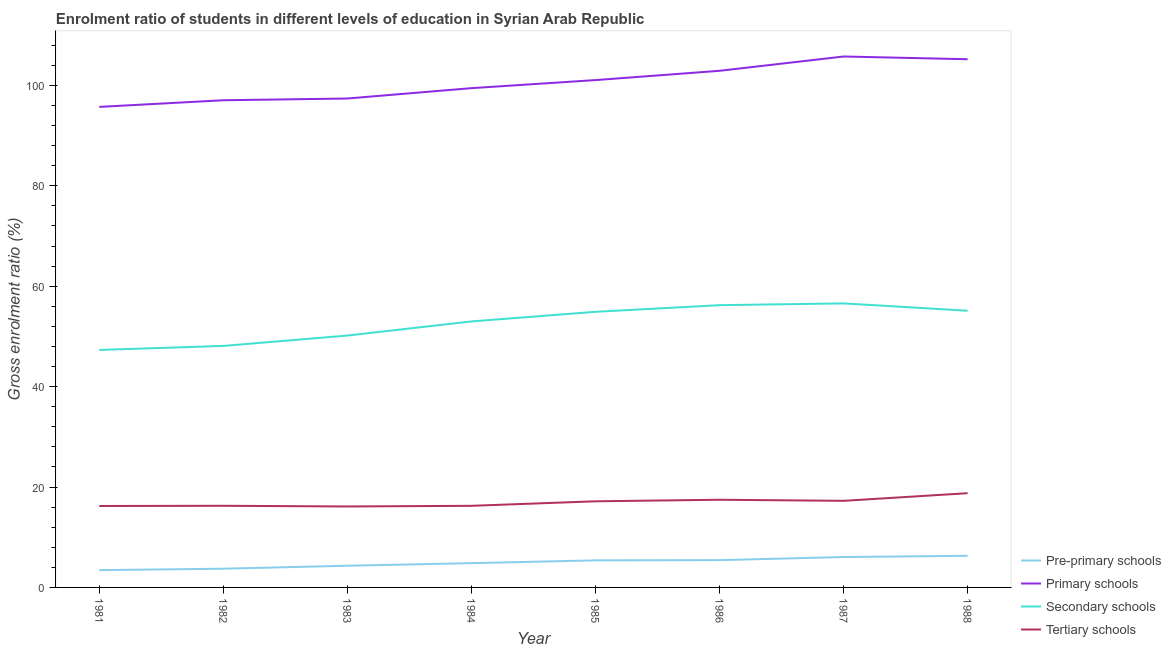Is the number of lines equal to the number of legend labels?
Make the answer very short. Yes. What is the gross enrolment ratio in secondary schools in 1985?
Your answer should be very brief. 54.9. Across all years, what is the maximum gross enrolment ratio in primary schools?
Make the answer very short. 105.76. Across all years, what is the minimum gross enrolment ratio in secondary schools?
Your answer should be very brief. 47.31. In which year was the gross enrolment ratio in pre-primary schools maximum?
Give a very brief answer. 1988. In which year was the gross enrolment ratio in pre-primary schools minimum?
Give a very brief answer. 1981. What is the total gross enrolment ratio in primary schools in the graph?
Your answer should be very brief. 804.57. What is the difference between the gross enrolment ratio in tertiary schools in 1982 and that in 1986?
Keep it short and to the point. -1.2. What is the difference between the gross enrolment ratio in pre-primary schools in 1984 and the gross enrolment ratio in secondary schools in 1985?
Your answer should be compact. -50.07. What is the average gross enrolment ratio in pre-primary schools per year?
Your response must be concise. 4.94. In the year 1986, what is the difference between the gross enrolment ratio in tertiary schools and gross enrolment ratio in secondary schools?
Give a very brief answer. -38.76. In how many years, is the gross enrolment ratio in pre-primary schools greater than 92 %?
Ensure brevity in your answer.  0. What is the ratio of the gross enrolment ratio in tertiary schools in 1985 to that in 1988?
Your answer should be compact. 0.91. Is the gross enrolment ratio in primary schools in 1981 less than that in 1987?
Your answer should be very brief. Yes. Is the difference between the gross enrolment ratio in secondary schools in 1984 and 1985 greater than the difference between the gross enrolment ratio in pre-primary schools in 1984 and 1985?
Your answer should be compact. No. What is the difference between the highest and the second highest gross enrolment ratio in primary schools?
Your response must be concise. 0.54. What is the difference between the highest and the lowest gross enrolment ratio in secondary schools?
Offer a terse response. 9.27. Is it the case that in every year, the sum of the gross enrolment ratio in primary schools and gross enrolment ratio in tertiary schools is greater than the sum of gross enrolment ratio in secondary schools and gross enrolment ratio in pre-primary schools?
Give a very brief answer. Yes. Is it the case that in every year, the sum of the gross enrolment ratio in pre-primary schools and gross enrolment ratio in primary schools is greater than the gross enrolment ratio in secondary schools?
Your response must be concise. Yes. Does the gross enrolment ratio in secondary schools monotonically increase over the years?
Your answer should be compact. No. Is the gross enrolment ratio in primary schools strictly greater than the gross enrolment ratio in secondary schools over the years?
Give a very brief answer. Yes. How many lines are there?
Your response must be concise. 4. Does the graph contain any zero values?
Your answer should be compact. No. What is the title of the graph?
Make the answer very short. Enrolment ratio of students in different levels of education in Syrian Arab Republic. What is the label or title of the X-axis?
Offer a very short reply. Year. What is the Gross enrolment ratio (%) of Pre-primary schools in 1981?
Offer a very short reply. 3.44. What is the Gross enrolment ratio (%) of Primary schools in 1981?
Provide a succinct answer. 95.72. What is the Gross enrolment ratio (%) in Secondary schools in 1981?
Provide a succinct answer. 47.31. What is the Gross enrolment ratio (%) in Tertiary schools in 1981?
Offer a very short reply. 16.22. What is the Gross enrolment ratio (%) in Pre-primary schools in 1982?
Give a very brief answer. 3.73. What is the Gross enrolment ratio (%) of Primary schools in 1982?
Offer a terse response. 97.05. What is the Gross enrolment ratio (%) in Secondary schools in 1982?
Offer a terse response. 48.11. What is the Gross enrolment ratio (%) in Tertiary schools in 1982?
Your response must be concise. 16.26. What is the Gross enrolment ratio (%) in Pre-primary schools in 1983?
Offer a very short reply. 4.32. What is the Gross enrolment ratio (%) of Primary schools in 1983?
Your answer should be very brief. 97.39. What is the Gross enrolment ratio (%) in Secondary schools in 1983?
Offer a terse response. 50.17. What is the Gross enrolment ratio (%) of Tertiary schools in 1983?
Your response must be concise. 16.13. What is the Gross enrolment ratio (%) of Pre-primary schools in 1984?
Your response must be concise. 4.84. What is the Gross enrolment ratio (%) of Primary schools in 1984?
Provide a succinct answer. 99.46. What is the Gross enrolment ratio (%) in Secondary schools in 1984?
Ensure brevity in your answer.  52.99. What is the Gross enrolment ratio (%) in Tertiary schools in 1984?
Your answer should be compact. 16.26. What is the Gross enrolment ratio (%) in Pre-primary schools in 1985?
Your answer should be compact. 5.39. What is the Gross enrolment ratio (%) in Primary schools in 1985?
Make the answer very short. 101.06. What is the Gross enrolment ratio (%) in Secondary schools in 1985?
Give a very brief answer. 54.9. What is the Gross enrolment ratio (%) in Tertiary schools in 1985?
Provide a short and direct response. 17.16. What is the Gross enrolment ratio (%) in Pre-primary schools in 1986?
Give a very brief answer. 5.44. What is the Gross enrolment ratio (%) in Primary schools in 1986?
Provide a short and direct response. 102.91. What is the Gross enrolment ratio (%) in Secondary schools in 1986?
Offer a very short reply. 56.23. What is the Gross enrolment ratio (%) of Tertiary schools in 1986?
Your response must be concise. 17.46. What is the Gross enrolment ratio (%) of Pre-primary schools in 1987?
Your answer should be compact. 6.05. What is the Gross enrolment ratio (%) in Primary schools in 1987?
Offer a very short reply. 105.76. What is the Gross enrolment ratio (%) in Secondary schools in 1987?
Offer a very short reply. 56.58. What is the Gross enrolment ratio (%) of Tertiary schools in 1987?
Give a very brief answer. 17.25. What is the Gross enrolment ratio (%) of Pre-primary schools in 1988?
Your answer should be compact. 6.3. What is the Gross enrolment ratio (%) in Primary schools in 1988?
Offer a very short reply. 105.22. What is the Gross enrolment ratio (%) of Secondary schools in 1988?
Your answer should be compact. 55.12. What is the Gross enrolment ratio (%) of Tertiary schools in 1988?
Offer a very short reply. 18.77. Across all years, what is the maximum Gross enrolment ratio (%) of Pre-primary schools?
Ensure brevity in your answer.  6.3. Across all years, what is the maximum Gross enrolment ratio (%) in Primary schools?
Offer a terse response. 105.76. Across all years, what is the maximum Gross enrolment ratio (%) in Secondary schools?
Offer a terse response. 56.58. Across all years, what is the maximum Gross enrolment ratio (%) in Tertiary schools?
Give a very brief answer. 18.77. Across all years, what is the minimum Gross enrolment ratio (%) in Pre-primary schools?
Your answer should be compact. 3.44. Across all years, what is the minimum Gross enrolment ratio (%) of Primary schools?
Provide a short and direct response. 95.72. Across all years, what is the minimum Gross enrolment ratio (%) of Secondary schools?
Offer a terse response. 47.31. Across all years, what is the minimum Gross enrolment ratio (%) of Tertiary schools?
Give a very brief answer. 16.13. What is the total Gross enrolment ratio (%) in Pre-primary schools in the graph?
Provide a short and direct response. 39.51. What is the total Gross enrolment ratio (%) in Primary schools in the graph?
Offer a terse response. 804.57. What is the total Gross enrolment ratio (%) of Secondary schools in the graph?
Your answer should be compact. 421.41. What is the total Gross enrolment ratio (%) in Tertiary schools in the graph?
Offer a very short reply. 135.52. What is the difference between the Gross enrolment ratio (%) in Pre-primary schools in 1981 and that in 1982?
Your response must be concise. -0.28. What is the difference between the Gross enrolment ratio (%) in Primary schools in 1981 and that in 1982?
Provide a short and direct response. -1.32. What is the difference between the Gross enrolment ratio (%) in Secondary schools in 1981 and that in 1982?
Your answer should be compact. -0.8. What is the difference between the Gross enrolment ratio (%) of Tertiary schools in 1981 and that in 1982?
Give a very brief answer. -0.04. What is the difference between the Gross enrolment ratio (%) of Pre-primary schools in 1981 and that in 1983?
Provide a succinct answer. -0.88. What is the difference between the Gross enrolment ratio (%) of Primary schools in 1981 and that in 1983?
Offer a very short reply. -1.67. What is the difference between the Gross enrolment ratio (%) in Secondary schools in 1981 and that in 1983?
Your answer should be very brief. -2.87. What is the difference between the Gross enrolment ratio (%) in Tertiary schools in 1981 and that in 1983?
Make the answer very short. 0.09. What is the difference between the Gross enrolment ratio (%) of Pre-primary schools in 1981 and that in 1984?
Your answer should be very brief. -1.39. What is the difference between the Gross enrolment ratio (%) in Primary schools in 1981 and that in 1984?
Offer a terse response. -3.73. What is the difference between the Gross enrolment ratio (%) in Secondary schools in 1981 and that in 1984?
Your response must be concise. -5.68. What is the difference between the Gross enrolment ratio (%) of Tertiary schools in 1981 and that in 1984?
Your answer should be compact. -0.04. What is the difference between the Gross enrolment ratio (%) of Pre-primary schools in 1981 and that in 1985?
Offer a very short reply. -1.95. What is the difference between the Gross enrolment ratio (%) of Primary schools in 1981 and that in 1985?
Give a very brief answer. -5.34. What is the difference between the Gross enrolment ratio (%) of Secondary schools in 1981 and that in 1985?
Make the answer very short. -7.6. What is the difference between the Gross enrolment ratio (%) of Tertiary schools in 1981 and that in 1985?
Give a very brief answer. -0.94. What is the difference between the Gross enrolment ratio (%) in Pre-primary schools in 1981 and that in 1986?
Provide a succinct answer. -1.99. What is the difference between the Gross enrolment ratio (%) in Primary schools in 1981 and that in 1986?
Ensure brevity in your answer.  -7.19. What is the difference between the Gross enrolment ratio (%) in Secondary schools in 1981 and that in 1986?
Keep it short and to the point. -8.92. What is the difference between the Gross enrolment ratio (%) in Tertiary schools in 1981 and that in 1986?
Provide a succinct answer. -1.24. What is the difference between the Gross enrolment ratio (%) of Pre-primary schools in 1981 and that in 1987?
Your answer should be compact. -2.61. What is the difference between the Gross enrolment ratio (%) of Primary schools in 1981 and that in 1987?
Your response must be concise. -10.04. What is the difference between the Gross enrolment ratio (%) in Secondary schools in 1981 and that in 1987?
Keep it short and to the point. -9.27. What is the difference between the Gross enrolment ratio (%) in Tertiary schools in 1981 and that in 1987?
Keep it short and to the point. -1.03. What is the difference between the Gross enrolment ratio (%) of Pre-primary schools in 1981 and that in 1988?
Your answer should be compact. -2.86. What is the difference between the Gross enrolment ratio (%) in Primary schools in 1981 and that in 1988?
Offer a terse response. -9.49. What is the difference between the Gross enrolment ratio (%) in Secondary schools in 1981 and that in 1988?
Ensure brevity in your answer.  -7.81. What is the difference between the Gross enrolment ratio (%) of Tertiary schools in 1981 and that in 1988?
Give a very brief answer. -2.55. What is the difference between the Gross enrolment ratio (%) of Pre-primary schools in 1982 and that in 1983?
Give a very brief answer. -0.59. What is the difference between the Gross enrolment ratio (%) in Primary schools in 1982 and that in 1983?
Offer a very short reply. -0.35. What is the difference between the Gross enrolment ratio (%) in Secondary schools in 1982 and that in 1983?
Offer a terse response. -2.07. What is the difference between the Gross enrolment ratio (%) in Tertiary schools in 1982 and that in 1983?
Offer a terse response. 0.13. What is the difference between the Gross enrolment ratio (%) in Pre-primary schools in 1982 and that in 1984?
Your response must be concise. -1.11. What is the difference between the Gross enrolment ratio (%) of Primary schools in 1982 and that in 1984?
Offer a terse response. -2.41. What is the difference between the Gross enrolment ratio (%) in Secondary schools in 1982 and that in 1984?
Provide a succinct answer. -4.88. What is the difference between the Gross enrolment ratio (%) of Tertiary schools in 1982 and that in 1984?
Your answer should be very brief. 0. What is the difference between the Gross enrolment ratio (%) in Pre-primary schools in 1982 and that in 1985?
Offer a terse response. -1.66. What is the difference between the Gross enrolment ratio (%) of Primary schools in 1982 and that in 1985?
Your answer should be compact. -4.02. What is the difference between the Gross enrolment ratio (%) in Secondary schools in 1982 and that in 1985?
Make the answer very short. -6.8. What is the difference between the Gross enrolment ratio (%) in Tertiary schools in 1982 and that in 1985?
Your answer should be very brief. -0.9. What is the difference between the Gross enrolment ratio (%) of Pre-primary schools in 1982 and that in 1986?
Offer a very short reply. -1.71. What is the difference between the Gross enrolment ratio (%) in Primary schools in 1982 and that in 1986?
Keep it short and to the point. -5.87. What is the difference between the Gross enrolment ratio (%) of Secondary schools in 1982 and that in 1986?
Offer a terse response. -8.12. What is the difference between the Gross enrolment ratio (%) in Tertiary schools in 1982 and that in 1986?
Ensure brevity in your answer.  -1.2. What is the difference between the Gross enrolment ratio (%) of Pre-primary schools in 1982 and that in 1987?
Keep it short and to the point. -2.33. What is the difference between the Gross enrolment ratio (%) in Primary schools in 1982 and that in 1987?
Offer a very short reply. -8.71. What is the difference between the Gross enrolment ratio (%) of Secondary schools in 1982 and that in 1987?
Provide a succinct answer. -8.47. What is the difference between the Gross enrolment ratio (%) in Tertiary schools in 1982 and that in 1987?
Make the answer very short. -0.99. What is the difference between the Gross enrolment ratio (%) of Pre-primary schools in 1982 and that in 1988?
Provide a succinct answer. -2.57. What is the difference between the Gross enrolment ratio (%) in Primary schools in 1982 and that in 1988?
Your response must be concise. -8.17. What is the difference between the Gross enrolment ratio (%) of Secondary schools in 1982 and that in 1988?
Offer a terse response. -7.01. What is the difference between the Gross enrolment ratio (%) in Tertiary schools in 1982 and that in 1988?
Provide a short and direct response. -2.51. What is the difference between the Gross enrolment ratio (%) of Pre-primary schools in 1983 and that in 1984?
Offer a terse response. -0.52. What is the difference between the Gross enrolment ratio (%) in Primary schools in 1983 and that in 1984?
Offer a very short reply. -2.06. What is the difference between the Gross enrolment ratio (%) in Secondary schools in 1983 and that in 1984?
Keep it short and to the point. -2.81. What is the difference between the Gross enrolment ratio (%) of Tertiary schools in 1983 and that in 1984?
Provide a short and direct response. -0.13. What is the difference between the Gross enrolment ratio (%) of Pre-primary schools in 1983 and that in 1985?
Your answer should be very brief. -1.07. What is the difference between the Gross enrolment ratio (%) of Primary schools in 1983 and that in 1985?
Offer a terse response. -3.67. What is the difference between the Gross enrolment ratio (%) in Secondary schools in 1983 and that in 1985?
Your response must be concise. -4.73. What is the difference between the Gross enrolment ratio (%) in Tertiary schools in 1983 and that in 1985?
Ensure brevity in your answer.  -1.03. What is the difference between the Gross enrolment ratio (%) in Pre-primary schools in 1983 and that in 1986?
Your answer should be compact. -1.12. What is the difference between the Gross enrolment ratio (%) in Primary schools in 1983 and that in 1986?
Make the answer very short. -5.52. What is the difference between the Gross enrolment ratio (%) in Secondary schools in 1983 and that in 1986?
Give a very brief answer. -6.05. What is the difference between the Gross enrolment ratio (%) in Tertiary schools in 1983 and that in 1986?
Your answer should be compact. -1.34. What is the difference between the Gross enrolment ratio (%) of Pre-primary schools in 1983 and that in 1987?
Your answer should be very brief. -1.73. What is the difference between the Gross enrolment ratio (%) of Primary schools in 1983 and that in 1987?
Ensure brevity in your answer.  -8.37. What is the difference between the Gross enrolment ratio (%) in Secondary schools in 1983 and that in 1987?
Offer a very short reply. -6.41. What is the difference between the Gross enrolment ratio (%) of Tertiary schools in 1983 and that in 1987?
Your response must be concise. -1.12. What is the difference between the Gross enrolment ratio (%) of Pre-primary schools in 1983 and that in 1988?
Provide a succinct answer. -1.98. What is the difference between the Gross enrolment ratio (%) in Primary schools in 1983 and that in 1988?
Provide a short and direct response. -7.82. What is the difference between the Gross enrolment ratio (%) in Secondary schools in 1983 and that in 1988?
Make the answer very short. -4.94. What is the difference between the Gross enrolment ratio (%) in Tertiary schools in 1983 and that in 1988?
Your response must be concise. -2.64. What is the difference between the Gross enrolment ratio (%) of Pre-primary schools in 1984 and that in 1985?
Make the answer very short. -0.56. What is the difference between the Gross enrolment ratio (%) of Primary schools in 1984 and that in 1985?
Provide a succinct answer. -1.61. What is the difference between the Gross enrolment ratio (%) of Secondary schools in 1984 and that in 1985?
Ensure brevity in your answer.  -1.92. What is the difference between the Gross enrolment ratio (%) of Tertiary schools in 1984 and that in 1985?
Keep it short and to the point. -0.9. What is the difference between the Gross enrolment ratio (%) in Pre-primary schools in 1984 and that in 1986?
Your answer should be compact. -0.6. What is the difference between the Gross enrolment ratio (%) in Primary schools in 1984 and that in 1986?
Offer a terse response. -3.46. What is the difference between the Gross enrolment ratio (%) of Secondary schools in 1984 and that in 1986?
Your response must be concise. -3.24. What is the difference between the Gross enrolment ratio (%) of Tertiary schools in 1984 and that in 1986?
Offer a very short reply. -1.21. What is the difference between the Gross enrolment ratio (%) of Pre-primary schools in 1984 and that in 1987?
Your answer should be compact. -1.22. What is the difference between the Gross enrolment ratio (%) in Primary schools in 1984 and that in 1987?
Provide a short and direct response. -6.3. What is the difference between the Gross enrolment ratio (%) of Secondary schools in 1984 and that in 1987?
Provide a succinct answer. -3.59. What is the difference between the Gross enrolment ratio (%) of Tertiary schools in 1984 and that in 1987?
Offer a terse response. -0.99. What is the difference between the Gross enrolment ratio (%) in Pre-primary schools in 1984 and that in 1988?
Make the answer very short. -1.47. What is the difference between the Gross enrolment ratio (%) in Primary schools in 1984 and that in 1988?
Keep it short and to the point. -5.76. What is the difference between the Gross enrolment ratio (%) in Secondary schools in 1984 and that in 1988?
Give a very brief answer. -2.13. What is the difference between the Gross enrolment ratio (%) in Tertiary schools in 1984 and that in 1988?
Your answer should be very brief. -2.51. What is the difference between the Gross enrolment ratio (%) of Pre-primary schools in 1985 and that in 1986?
Provide a short and direct response. -0.04. What is the difference between the Gross enrolment ratio (%) in Primary schools in 1985 and that in 1986?
Give a very brief answer. -1.85. What is the difference between the Gross enrolment ratio (%) of Secondary schools in 1985 and that in 1986?
Keep it short and to the point. -1.32. What is the difference between the Gross enrolment ratio (%) in Tertiary schools in 1985 and that in 1986?
Keep it short and to the point. -0.31. What is the difference between the Gross enrolment ratio (%) in Pre-primary schools in 1985 and that in 1987?
Your answer should be compact. -0.66. What is the difference between the Gross enrolment ratio (%) of Primary schools in 1985 and that in 1987?
Keep it short and to the point. -4.7. What is the difference between the Gross enrolment ratio (%) of Secondary schools in 1985 and that in 1987?
Your answer should be very brief. -1.68. What is the difference between the Gross enrolment ratio (%) in Tertiary schools in 1985 and that in 1987?
Provide a succinct answer. -0.09. What is the difference between the Gross enrolment ratio (%) of Pre-primary schools in 1985 and that in 1988?
Ensure brevity in your answer.  -0.91. What is the difference between the Gross enrolment ratio (%) of Primary schools in 1985 and that in 1988?
Keep it short and to the point. -4.16. What is the difference between the Gross enrolment ratio (%) of Secondary schools in 1985 and that in 1988?
Your response must be concise. -0.21. What is the difference between the Gross enrolment ratio (%) of Tertiary schools in 1985 and that in 1988?
Keep it short and to the point. -1.61. What is the difference between the Gross enrolment ratio (%) in Pre-primary schools in 1986 and that in 1987?
Provide a succinct answer. -0.62. What is the difference between the Gross enrolment ratio (%) of Primary schools in 1986 and that in 1987?
Your response must be concise. -2.85. What is the difference between the Gross enrolment ratio (%) in Secondary schools in 1986 and that in 1987?
Offer a terse response. -0.35. What is the difference between the Gross enrolment ratio (%) in Tertiary schools in 1986 and that in 1987?
Your answer should be compact. 0.21. What is the difference between the Gross enrolment ratio (%) of Pre-primary schools in 1986 and that in 1988?
Your response must be concise. -0.87. What is the difference between the Gross enrolment ratio (%) in Primary schools in 1986 and that in 1988?
Provide a succinct answer. -2.31. What is the difference between the Gross enrolment ratio (%) in Secondary schools in 1986 and that in 1988?
Provide a short and direct response. 1.11. What is the difference between the Gross enrolment ratio (%) of Tertiary schools in 1986 and that in 1988?
Offer a terse response. -1.31. What is the difference between the Gross enrolment ratio (%) of Pre-primary schools in 1987 and that in 1988?
Offer a terse response. -0.25. What is the difference between the Gross enrolment ratio (%) of Primary schools in 1987 and that in 1988?
Your answer should be very brief. 0.54. What is the difference between the Gross enrolment ratio (%) in Secondary schools in 1987 and that in 1988?
Ensure brevity in your answer.  1.46. What is the difference between the Gross enrolment ratio (%) in Tertiary schools in 1987 and that in 1988?
Offer a very short reply. -1.52. What is the difference between the Gross enrolment ratio (%) in Pre-primary schools in 1981 and the Gross enrolment ratio (%) in Primary schools in 1982?
Your answer should be compact. -93.6. What is the difference between the Gross enrolment ratio (%) in Pre-primary schools in 1981 and the Gross enrolment ratio (%) in Secondary schools in 1982?
Make the answer very short. -44.66. What is the difference between the Gross enrolment ratio (%) of Pre-primary schools in 1981 and the Gross enrolment ratio (%) of Tertiary schools in 1982?
Keep it short and to the point. -12.82. What is the difference between the Gross enrolment ratio (%) in Primary schools in 1981 and the Gross enrolment ratio (%) in Secondary schools in 1982?
Make the answer very short. 47.62. What is the difference between the Gross enrolment ratio (%) of Primary schools in 1981 and the Gross enrolment ratio (%) of Tertiary schools in 1982?
Your answer should be compact. 79.46. What is the difference between the Gross enrolment ratio (%) in Secondary schools in 1981 and the Gross enrolment ratio (%) in Tertiary schools in 1982?
Give a very brief answer. 31.05. What is the difference between the Gross enrolment ratio (%) of Pre-primary schools in 1981 and the Gross enrolment ratio (%) of Primary schools in 1983?
Ensure brevity in your answer.  -93.95. What is the difference between the Gross enrolment ratio (%) in Pre-primary schools in 1981 and the Gross enrolment ratio (%) in Secondary schools in 1983?
Provide a short and direct response. -46.73. What is the difference between the Gross enrolment ratio (%) in Pre-primary schools in 1981 and the Gross enrolment ratio (%) in Tertiary schools in 1983?
Your response must be concise. -12.68. What is the difference between the Gross enrolment ratio (%) of Primary schools in 1981 and the Gross enrolment ratio (%) of Secondary schools in 1983?
Offer a terse response. 45.55. What is the difference between the Gross enrolment ratio (%) in Primary schools in 1981 and the Gross enrolment ratio (%) in Tertiary schools in 1983?
Provide a succinct answer. 79.6. What is the difference between the Gross enrolment ratio (%) of Secondary schools in 1981 and the Gross enrolment ratio (%) of Tertiary schools in 1983?
Make the answer very short. 31.18. What is the difference between the Gross enrolment ratio (%) of Pre-primary schools in 1981 and the Gross enrolment ratio (%) of Primary schools in 1984?
Your response must be concise. -96.01. What is the difference between the Gross enrolment ratio (%) of Pre-primary schools in 1981 and the Gross enrolment ratio (%) of Secondary schools in 1984?
Make the answer very short. -49.54. What is the difference between the Gross enrolment ratio (%) in Pre-primary schools in 1981 and the Gross enrolment ratio (%) in Tertiary schools in 1984?
Ensure brevity in your answer.  -12.81. What is the difference between the Gross enrolment ratio (%) in Primary schools in 1981 and the Gross enrolment ratio (%) in Secondary schools in 1984?
Offer a very short reply. 42.74. What is the difference between the Gross enrolment ratio (%) of Primary schools in 1981 and the Gross enrolment ratio (%) of Tertiary schools in 1984?
Give a very brief answer. 79.47. What is the difference between the Gross enrolment ratio (%) in Secondary schools in 1981 and the Gross enrolment ratio (%) in Tertiary schools in 1984?
Ensure brevity in your answer.  31.05. What is the difference between the Gross enrolment ratio (%) of Pre-primary schools in 1981 and the Gross enrolment ratio (%) of Primary schools in 1985?
Give a very brief answer. -97.62. What is the difference between the Gross enrolment ratio (%) of Pre-primary schools in 1981 and the Gross enrolment ratio (%) of Secondary schools in 1985?
Provide a succinct answer. -51.46. What is the difference between the Gross enrolment ratio (%) in Pre-primary schools in 1981 and the Gross enrolment ratio (%) in Tertiary schools in 1985?
Your answer should be very brief. -13.71. What is the difference between the Gross enrolment ratio (%) of Primary schools in 1981 and the Gross enrolment ratio (%) of Secondary schools in 1985?
Ensure brevity in your answer.  40.82. What is the difference between the Gross enrolment ratio (%) of Primary schools in 1981 and the Gross enrolment ratio (%) of Tertiary schools in 1985?
Offer a terse response. 78.57. What is the difference between the Gross enrolment ratio (%) of Secondary schools in 1981 and the Gross enrolment ratio (%) of Tertiary schools in 1985?
Give a very brief answer. 30.15. What is the difference between the Gross enrolment ratio (%) of Pre-primary schools in 1981 and the Gross enrolment ratio (%) of Primary schools in 1986?
Ensure brevity in your answer.  -99.47. What is the difference between the Gross enrolment ratio (%) in Pre-primary schools in 1981 and the Gross enrolment ratio (%) in Secondary schools in 1986?
Provide a succinct answer. -52.78. What is the difference between the Gross enrolment ratio (%) in Pre-primary schools in 1981 and the Gross enrolment ratio (%) in Tertiary schools in 1986?
Give a very brief answer. -14.02. What is the difference between the Gross enrolment ratio (%) of Primary schools in 1981 and the Gross enrolment ratio (%) of Secondary schools in 1986?
Provide a short and direct response. 39.5. What is the difference between the Gross enrolment ratio (%) of Primary schools in 1981 and the Gross enrolment ratio (%) of Tertiary schools in 1986?
Offer a terse response. 78.26. What is the difference between the Gross enrolment ratio (%) of Secondary schools in 1981 and the Gross enrolment ratio (%) of Tertiary schools in 1986?
Your answer should be compact. 29.84. What is the difference between the Gross enrolment ratio (%) in Pre-primary schools in 1981 and the Gross enrolment ratio (%) in Primary schools in 1987?
Your answer should be very brief. -102.32. What is the difference between the Gross enrolment ratio (%) of Pre-primary schools in 1981 and the Gross enrolment ratio (%) of Secondary schools in 1987?
Keep it short and to the point. -53.14. What is the difference between the Gross enrolment ratio (%) of Pre-primary schools in 1981 and the Gross enrolment ratio (%) of Tertiary schools in 1987?
Your response must be concise. -13.81. What is the difference between the Gross enrolment ratio (%) of Primary schools in 1981 and the Gross enrolment ratio (%) of Secondary schools in 1987?
Provide a succinct answer. 39.14. What is the difference between the Gross enrolment ratio (%) of Primary schools in 1981 and the Gross enrolment ratio (%) of Tertiary schools in 1987?
Ensure brevity in your answer.  78.47. What is the difference between the Gross enrolment ratio (%) in Secondary schools in 1981 and the Gross enrolment ratio (%) in Tertiary schools in 1987?
Your answer should be very brief. 30.06. What is the difference between the Gross enrolment ratio (%) of Pre-primary schools in 1981 and the Gross enrolment ratio (%) of Primary schools in 1988?
Offer a very short reply. -101.77. What is the difference between the Gross enrolment ratio (%) of Pre-primary schools in 1981 and the Gross enrolment ratio (%) of Secondary schools in 1988?
Give a very brief answer. -51.67. What is the difference between the Gross enrolment ratio (%) of Pre-primary schools in 1981 and the Gross enrolment ratio (%) of Tertiary schools in 1988?
Provide a succinct answer. -15.33. What is the difference between the Gross enrolment ratio (%) in Primary schools in 1981 and the Gross enrolment ratio (%) in Secondary schools in 1988?
Provide a short and direct response. 40.61. What is the difference between the Gross enrolment ratio (%) of Primary schools in 1981 and the Gross enrolment ratio (%) of Tertiary schools in 1988?
Make the answer very short. 76.95. What is the difference between the Gross enrolment ratio (%) in Secondary schools in 1981 and the Gross enrolment ratio (%) in Tertiary schools in 1988?
Your answer should be very brief. 28.54. What is the difference between the Gross enrolment ratio (%) in Pre-primary schools in 1982 and the Gross enrolment ratio (%) in Primary schools in 1983?
Offer a terse response. -93.67. What is the difference between the Gross enrolment ratio (%) of Pre-primary schools in 1982 and the Gross enrolment ratio (%) of Secondary schools in 1983?
Your response must be concise. -46.45. What is the difference between the Gross enrolment ratio (%) in Pre-primary schools in 1982 and the Gross enrolment ratio (%) in Tertiary schools in 1983?
Offer a very short reply. -12.4. What is the difference between the Gross enrolment ratio (%) of Primary schools in 1982 and the Gross enrolment ratio (%) of Secondary schools in 1983?
Keep it short and to the point. 46.87. What is the difference between the Gross enrolment ratio (%) of Primary schools in 1982 and the Gross enrolment ratio (%) of Tertiary schools in 1983?
Provide a succinct answer. 80.92. What is the difference between the Gross enrolment ratio (%) of Secondary schools in 1982 and the Gross enrolment ratio (%) of Tertiary schools in 1983?
Provide a succinct answer. 31.98. What is the difference between the Gross enrolment ratio (%) of Pre-primary schools in 1982 and the Gross enrolment ratio (%) of Primary schools in 1984?
Your response must be concise. -95.73. What is the difference between the Gross enrolment ratio (%) of Pre-primary schools in 1982 and the Gross enrolment ratio (%) of Secondary schools in 1984?
Your answer should be compact. -49.26. What is the difference between the Gross enrolment ratio (%) of Pre-primary schools in 1982 and the Gross enrolment ratio (%) of Tertiary schools in 1984?
Your response must be concise. -12.53. What is the difference between the Gross enrolment ratio (%) of Primary schools in 1982 and the Gross enrolment ratio (%) of Secondary schools in 1984?
Keep it short and to the point. 44.06. What is the difference between the Gross enrolment ratio (%) of Primary schools in 1982 and the Gross enrolment ratio (%) of Tertiary schools in 1984?
Ensure brevity in your answer.  80.79. What is the difference between the Gross enrolment ratio (%) of Secondary schools in 1982 and the Gross enrolment ratio (%) of Tertiary schools in 1984?
Make the answer very short. 31.85. What is the difference between the Gross enrolment ratio (%) in Pre-primary schools in 1982 and the Gross enrolment ratio (%) in Primary schools in 1985?
Give a very brief answer. -97.33. What is the difference between the Gross enrolment ratio (%) in Pre-primary schools in 1982 and the Gross enrolment ratio (%) in Secondary schools in 1985?
Keep it short and to the point. -51.18. What is the difference between the Gross enrolment ratio (%) in Pre-primary schools in 1982 and the Gross enrolment ratio (%) in Tertiary schools in 1985?
Keep it short and to the point. -13.43. What is the difference between the Gross enrolment ratio (%) in Primary schools in 1982 and the Gross enrolment ratio (%) in Secondary schools in 1985?
Offer a terse response. 42.14. What is the difference between the Gross enrolment ratio (%) of Primary schools in 1982 and the Gross enrolment ratio (%) of Tertiary schools in 1985?
Offer a terse response. 79.89. What is the difference between the Gross enrolment ratio (%) in Secondary schools in 1982 and the Gross enrolment ratio (%) in Tertiary schools in 1985?
Your answer should be very brief. 30.95. What is the difference between the Gross enrolment ratio (%) in Pre-primary schools in 1982 and the Gross enrolment ratio (%) in Primary schools in 1986?
Make the answer very short. -99.18. What is the difference between the Gross enrolment ratio (%) in Pre-primary schools in 1982 and the Gross enrolment ratio (%) in Secondary schools in 1986?
Make the answer very short. -52.5. What is the difference between the Gross enrolment ratio (%) in Pre-primary schools in 1982 and the Gross enrolment ratio (%) in Tertiary schools in 1986?
Give a very brief answer. -13.74. What is the difference between the Gross enrolment ratio (%) of Primary schools in 1982 and the Gross enrolment ratio (%) of Secondary schools in 1986?
Your answer should be very brief. 40.82. What is the difference between the Gross enrolment ratio (%) of Primary schools in 1982 and the Gross enrolment ratio (%) of Tertiary schools in 1986?
Your answer should be compact. 79.58. What is the difference between the Gross enrolment ratio (%) of Secondary schools in 1982 and the Gross enrolment ratio (%) of Tertiary schools in 1986?
Offer a very short reply. 30.64. What is the difference between the Gross enrolment ratio (%) of Pre-primary schools in 1982 and the Gross enrolment ratio (%) of Primary schools in 1987?
Your answer should be very brief. -102.03. What is the difference between the Gross enrolment ratio (%) of Pre-primary schools in 1982 and the Gross enrolment ratio (%) of Secondary schools in 1987?
Offer a very short reply. -52.85. What is the difference between the Gross enrolment ratio (%) in Pre-primary schools in 1982 and the Gross enrolment ratio (%) in Tertiary schools in 1987?
Your response must be concise. -13.52. What is the difference between the Gross enrolment ratio (%) of Primary schools in 1982 and the Gross enrolment ratio (%) of Secondary schools in 1987?
Ensure brevity in your answer.  40.47. What is the difference between the Gross enrolment ratio (%) in Primary schools in 1982 and the Gross enrolment ratio (%) in Tertiary schools in 1987?
Offer a very short reply. 79.79. What is the difference between the Gross enrolment ratio (%) of Secondary schools in 1982 and the Gross enrolment ratio (%) of Tertiary schools in 1987?
Provide a short and direct response. 30.86. What is the difference between the Gross enrolment ratio (%) in Pre-primary schools in 1982 and the Gross enrolment ratio (%) in Primary schools in 1988?
Make the answer very short. -101.49. What is the difference between the Gross enrolment ratio (%) in Pre-primary schools in 1982 and the Gross enrolment ratio (%) in Secondary schools in 1988?
Your answer should be very brief. -51.39. What is the difference between the Gross enrolment ratio (%) in Pre-primary schools in 1982 and the Gross enrolment ratio (%) in Tertiary schools in 1988?
Your answer should be compact. -15.04. What is the difference between the Gross enrolment ratio (%) of Primary schools in 1982 and the Gross enrolment ratio (%) of Secondary schools in 1988?
Your answer should be very brief. 41.93. What is the difference between the Gross enrolment ratio (%) of Primary schools in 1982 and the Gross enrolment ratio (%) of Tertiary schools in 1988?
Your answer should be compact. 78.27. What is the difference between the Gross enrolment ratio (%) in Secondary schools in 1982 and the Gross enrolment ratio (%) in Tertiary schools in 1988?
Make the answer very short. 29.34. What is the difference between the Gross enrolment ratio (%) of Pre-primary schools in 1983 and the Gross enrolment ratio (%) of Primary schools in 1984?
Your answer should be very brief. -95.14. What is the difference between the Gross enrolment ratio (%) of Pre-primary schools in 1983 and the Gross enrolment ratio (%) of Secondary schools in 1984?
Offer a terse response. -48.67. What is the difference between the Gross enrolment ratio (%) of Pre-primary schools in 1983 and the Gross enrolment ratio (%) of Tertiary schools in 1984?
Make the answer very short. -11.94. What is the difference between the Gross enrolment ratio (%) in Primary schools in 1983 and the Gross enrolment ratio (%) in Secondary schools in 1984?
Provide a succinct answer. 44.41. What is the difference between the Gross enrolment ratio (%) of Primary schools in 1983 and the Gross enrolment ratio (%) of Tertiary schools in 1984?
Offer a very short reply. 81.14. What is the difference between the Gross enrolment ratio (%) of Secondary schools in 1983 and the Gross enrolment ratio (%) of Tertiary schools in 1984?
Your answer should be very brief. 33.92. What is the difference between the Gross enrolment ratio (%) in Pre-primary schools in 1983 and the Gross enrolment ratio (%) in Primary schools in 1985?
Give a very brief answer. -96.74. What is the difference between the Gross enrolment ratio (%) in Pre-primary schools in 1983 and the Gross enrolment ratio (%) in Secondary schools in 1985?
Ensure brevity in your answer.  -50.58. What is the difference between the Gross enrolment ratio (%) in Pre-primary schools in 1983 and the Gross enrolment ratio (%) in Tertiary schools in 1985?
Provide a short and direct response. -12.84. What is the difference between the Gross enrolment ratio (%) of Primary schools in 1983 and the Gross enrolment ratio (%) of Secondary schools in 1985?
Provide a succinct answer. 42.49. What is the difference between the Gross enrolment ratio (%) of Primary schools in 1983 and the Gross enrolment ratio (%) of Tertiary schools in 1985?
Your answer should be very brief. 80.24. What is the difference between the Gross enrolment ratio (%) in Secondary schools in 1983 and the Gross enrolment ratio (%) in Tertiary schools in 1985?
Offer a very short reply. 33.02. What is the difference between the Gross enrolment ratio (%) in Pre-primary schools in 1983 and the Gross enrolment ratio (%) in Primary schools in 1986?
Your response must be concise. -98.59. What is the difference between the Gross enrolment ratio (%) in Pre-primary schools in 1983 and the Gross enrolment ratio (%) in Secondary schools in 1986?
Ensure brevity in your answer.  -51.91. What is the difference between the Gross enrolment ratio (%) in Pre-primary schools in 1983 and the Gross enrolment ratio (%) in Tertiary schools in 1986?
Your response must be concise. -13.14. What is the difference between the Gross enrolment ratio (%) in Primary schools in 1983 and the Gross enrolment ratio (%) in Secondary schools in 1986?
Provide a succinct answer. 41.17. What is the difference between the Gross enrolment ratio (%) of Primary schools in 1983 and the Gross enrolment ratio (%) of Tertiary schools in 1986?
Offer a very short reply. 79.93. What is the difference between the Gross enrolment ratio (%) in Secondary schools in 1983 and the Gross enrolment ratio (%) in Tertiary schools in 1986?
Keep it short and to the point. 32.71. What is the difference between the Gross enrolment ratio (%) in Pre-primary schools in 1983 and the Gross enrolment ratio (%) in Primary schools in 1987?
Your answer should be compact. -101.44. What is the difference between the Gross enrolment ratio (%) in Pre-primary schools in 1983 and the Gross enrolment ratio (%) in Secondary schools in 1987?
Provide a short and direct response. -52.26. What is the difference between the Gross enrolment ratio (%) of Pre-primary schools in 1983 and the Gross enrolment ratio (%) of Tertiary schools in 1987?
Keep it short and to the point. -12.93. What is the difference between the Gross enrolment ratio (%) of Primary schools in 1983 and the Gross enrolment ratio (%) of Secondary schools in 1987?
Your answer should be very brief. 40.81. What is the difference between the Gross enrolment ratio (%) of Primary schools in 1983 and the Gross enrolment ratio (%) of Tertiary schools in 1987?
Provide a succinct answer. 80.14. What is the difference between the Gross enrolment ratio (%) in Secondary schools in 1983 and the Gross enrolment ratio (%) in Tertiary schools in 1987?
Make the answer very short. 32.92. What is the difference between the Gross enrolment ratio (%) of Pre-primary schools in 1983 and the Gross enrolment ratio (%) of Primary schools in 1988?
Your answer should be very brief. -100.9. What is the difference between the Gross enrolment ratio (%) of Pre-primary schools in 1983 and the Gross enrolment ratio (%) of Secondary schools in 1988?
Offer a terse response. -50.8. What is the difference between the Gross enrolment ratio (%) in Pre-primary schools in 1983 and the Gross enrolment ratio (%) in Tertiary schools in 1988?
Give a very brief answer. -14.45. What is the difference between the Gross enrolment ratio (%) of Primary schools in 1983 and the Gross enrolment ratio (%) of Secondary schools in 1988?
Offer a very short reply. 42.28. What is the difference between the Gross enrolment ratio (%) of Primary schools in 1983 and the Gross enrolment ratio (%) of Tertiary schools in 1988?
Offer a terse response. 78.62. What is the difference between the Gross enrolment ratio (%) in Secondary schools in 1983 and the Gross enrolment ratio (%) in Tertiary schools in 1988?
Keep it short and to the point. 31.4. What is the difference between the Gross enrolment ratio (%) in Pre-primary schools in 1984 and the Gross enrolment ratio (%) in Primary schools in 1985?
Provide a short and direct response. -96.23. What is the difference between the Gross enrolment ratio (%) in Pre-primary schools in 1984 and the Gross enrolment ratio (%) in Secondary schools in 1985?
Make the answer very short. -50.07. What is the difference between the Gross enrolment ratio (%) of Pre-primary schools in 1984 and the Gross enrolment ratio (%) of Tertiary schools in 1985?
Make the answer very short. -12.32. What is the difference between the Gross enrolment ratio (%) of Primary schools in 1984 and the Gross enrolment ratio (%) of Secondary schools in 1985?
Offer a very short reply. 44.55. What is the difference between the Gross enrolment ratio (%) in Primary schools in 1984 and the Gross enrolment ratio (%) in Tertiary schools in 1985?
Offer a terse response. 82.3. What is the difference between the Gross enrolment ratio (%) of Secondary schools in 1984 and the Gross enrolment ratio (%) of Tertiary schools in 1985?
Provide a succinct answer. 35.83. What is the difference between the Gross enrolment ratio (%) in Pre-primary schools in 1984 and the Gross enrolment ratio (%) in Primary schools in 1986?
Make the answer very short. -98.08. What is the difference between the Gross enrolment ratio (%) in Pre-primary schools in 1984 and the Gross enrolment ratio (%) in Secondary schools in 1986?
Give a very brief answer. -51.39. What is the difference between the Gross enrolment ratio (%) of Pre-primary schools in 1984 and the Gross enrolment ratio (%) of Tertiary schools in 1986?
Make the answer very short. -12.63. What is the difference between the Gross enrolment ratio (%) of Primary schools in 1984 and the Gross enrolment ratio (%) of Secondary schools in 1986?
Your answer should be compact. 43.23. What is the difference between the Gross enrolment ratio (%) in Primary schools in 1984 and the Gross enrolment ratio (%) in Tertiary schools in 1986?
Provide a succinct answer. 81.99. What is the difference between the Gross enrolment ratio (%) of Secondary schools in 1984 and the Gross enrolment ratio (%) of Tertiary schools in 1986?
Make the answer very short. 35.52. What is the difference between the Gross enrolment ratio (%) of Pre-primary schools in 1984 and the Gross enrolment ratio (%) of Primary schools in 1987?
Offer a terse response. -100.93. What is the difference between the Gross enrolment ratio (%) of Pre-primary schools in 1984 and the Gross enrolment ratio (%) of Secondary schools in 1987?
Offer a terse response. -51.75. What is the difference between the Gross enrolment ratio (%) in Pre-primary schools in 1984 and the Gross enrolment ratio (%) in Tertiary schools in 1987?
Offer a terse response. -12.42. What is the difference between the Gross enrolment ratio (%) of Primary schools in 1984 and the Gross enrolment ratio (%) of Secondary schools in 1987?
Give a very brief answer. 42.88. What is the difference between the Gross enrolment ratio (%) of Primary schools in 1984 and the Gross enrolment ratio (%) of Tertiary schools in 1987?
Offer a very short reply. 82.21. What is the difference between the Gross enrolment ratio (%) in Secondary schools in 1984 and the Gross enrolment ratio (%) in Tertiary schools in 1987?
Ensure brevity in your answer.  35.74. What is the difference between the Gross enrolment ratio (%) of Pre-primary schools in 1984 and the Gross enrolment ratio (%) of Primary schools in 1988?
Ensure brevity in your answer.  -100.38. What is the difference between the Gross enrolment ratio (%) of Pre-primary schools in 1984 and the Gross enrolment ratio (%) of Secondary schools in 1988?
Give a very brief answer. -50.28. What is the difference between the Gross enrolment ratio (%) of Pre-primary schools in 1984 and the Gross enrolment ratio (%) of Tertiary schools in 1988?
Offer a terse response. -13.94. What is the difference between the Gross enrolment ratio (%) of Primary schools in 1984 and the Gross enrolment ratio (%) of Secondary schools in 1988?
Your response must be concise. 44.34. What is the difference between the Gross enrolment ratio (%) of Primary schools in 1984 and the Gross enrolment ratio (%) of Tertiary schools in 1988?
Provide a succinct answer. 80.69. What is the difference between the Gross enrolment ratio (%) of Secondary schools in 1984 and the Gross enrolment ratio (%) of Tertiary schools in 1988?
Keep it short and to the point. 34.22. What is the difference between the Gross enrolment ratio (%) in Pre-primary schools in 1985 and the Gross enrolment ratio (%) in Primary schools in 1986?
Your response must be concise. -97.52. What is the difference between the Gross enrolment ratio (%) in Pre-primary schools in 1985 and the Gross enrolment ratio (%) in Secondary schools in 1986?
Offer a terse response. -50.83. What is the difference between the Gross enrolment ratio (%) in Pre-primary schools in 1985 and the Gross enrolment ratio (%) in Tertiary schools in 1986?
Provide a succinct answer. -12.07. What is the difference between the Gross enrolment ratio (%) in Primary schools in 1985 and the Gross enrolment ratio (%) in Secondary schools in 1986?
Keep it short and to the point. 44.84. What is the difference between the Gross enrolment ratio (%) of Primary schools in 1985 and the Gross enrolment ratio (%) of Tertiary schools in 1986?
Make the answer very short. 83.6. What is the difference between the Gross enrolment ratio (%) in Secondary schools in 1985 and the Gross enrolment ratio (%) in Tertiary schools in 1986?
Offer a very short reply. 37.44. What is the difference between the Gross enrolment ratio (%) of Pre-primary schools in 1985 and the Gross enrolment ratio (%) of Primary schools in 1987?
Give a very brief answer. -100.37. What is the difference between the Gross enrolment ratio (%) of Pre-primary schools in 1985 and the Gross enrolment ratio (%) of Secondary schools in 1987?
Offer a very short reply. -51.19. What is the difference between the Gross enrolment ratio (%) of Pre-primary schools in 1985 and the Gross enrolment ratio (%) of Tertiary schools in 1987?
Keep it short and to the point. -11.86. What is the difference between the Gross enrolment ratio (%) of Primary schools in 1985 and the Gross enrolment ratio (%) of Secondary schools in 1987?
Provide a short and direct response. 44.48. What is the difference between the Gross enrolment ratio (%) in Primary schools in 1985 and the Gross enrolment ratio (%) in Tertiary schools in 1987?
Give a very brief answer. 83.81. What is the difference between the Gross enrolment ratio (%) of Secondary schools in 1985 and the Gross enrolment ratio (%) of Tertiary schools in 1987?
Give a very brief answer. 37.65. What is the difference between the Gross enrolment ratio (%) in Pre-primary schools in 1985 and the Gross enrolment ratio (%) in Primary schools in 1988?
Your answer should be very brief. -99.82. What is the difference between the Gross enrolment ratio (%) of Pre-primary schools in 1985 and the Gross enrolment ratio (%) of Secondary schools in 1988?
Your answer should be compact. -49.72. What is the difference between the Gross enrolment ratio (%) of Pre-primary schools in 1985 and the Gross enrolment ratio (%) of Tertiary schools in 1988?
Offer a very short reply. -13.38. What is the difference between the Gross enrolment ratio (%) of Primary schools in 1985 and the Gross enrolment ratio (%) of Secondary schools in 1988?
Ensure brevity in your answer.  45.95. What is the difference between the Gross enrolment ratio (%) of Primary schools in 1985 and the Gross enrolment ratio (%) of Tertiary schools in 1988?
Ensure brevity in your answer.  82.29. What is the difference between the Gross enrolment ratio (%) in Secondary schools in 1985 and the Gross enrolment ratio (%) in Tertiary schools in 1988?
Provide a short and direct response. 36.13. What is the difference between the Gross enrolment ratio (%) of Pre-primary schools in 1986 and the Gross enrolment ratio (%) of Primary schools in 1987?
Provide a short and direct response. -100.32. What is the difference between the Gross enrolment ratio (%) of Pre-primary schools in 1986 and the Gross enrolment ratio (%) of Secondary schools in 1987?
Ensure brevity in your answer.  -51.15. What is the difference between the Gross enrolment ratio (%) of Pre-primary schools in 1986 and the Gross enrolment ratio (%) of Tertiary schools in 1987?
Your response must be concise. -11.82. What is the difference between the Gross enrolment ratio (%) of Primary schools in 1986 and the Gross enrolment ratio (%) of Secondary schools in 1987?
Give a very brief answer. 46.33. What is the difference between the Gross enrolment ratio (%) in Primary schools in 1986 and the Gross enrolment ratio (%) in Tertiary schools in 1987?
Make the answer very short. 85.66. What is the difference between the Gross enrolment ratio (%) of Secondary schools in 1986 and the Gross enrolment ratio (%) of Tertiary schools in 1987?
Offer a very short reply. 38.98. What is the difference between the Gross enrolment ratio (%) in Pre-primary schools in 1986 and the Gross enrolment ratio (%) in Primary schools in 1988?
Offer a terse response. -99.78. What is the difference between the Gross enrolment ratio (%) in Pre-primary schools in 1986 and the Gross enrolment ratio (%) in Secondary schools in 1988?
Keep it short and to the point. -49.68. What is the difference between the Gross enrolment ratio (%) of Pre-primary schools in 1986 and the Gross enrolment ratio (%) of Tertiary schools in 1988?
Make the answer very short. -13.34. What is the difference between the Gross enrolment ratio (%) of Primary schools in 1986 and the Gross enrolment ratio (%) of Secondary schools in 1988?
Your answer should be compact. 47.8. What is the difference between the Gross enrolment ratio (%) of Primary schools in 1986 and the Gross enrolment ratio (%) of Tertiary schools in 1988?
Offer a terse response. 84.14. What is the difference between the Gross enrolment ratio (%) of Secondary schools in 1986 and the Gross enrolment ratio (%) of Tertiary schools in 1988?
Make the answer very short. 37.46. What is the difference between the Gross enrolment ratio (%) of Pre-primary schools in 1987 and the Gross enrolment ratio (%) of Primary schools in 1988?
Your answer should be very brief. -99.16. What is the difference between the Gross enrolment ratio (%) of Pre-primary schools in 1987 and the Gross enrolment ratio (%) of Secondary schools in 1988?
Make the answer very short. -49.06. What is the difference between the Gross enrolment ratio (%) in Pre-primary schools in 1987 and the Gross enrolment ratio (%) in Tertiary schools in 1988?
Give a very brief answer. -12.72. What is the difference between the Gross enrolment ratio (%) of Primary schools in 1987 and the Gross enrolment ratio (%) of Secondary schools in 1988?
Offer a very short reply. 50.64. What is the difference between the Gross enrolment ratio (%) in Primary schools in 1987 and the Gross enrolment ratio (%) in Tertiary schools in 1988?
Your answer should be very brief. 86.99. What is the difference between the Gross enrolment ratio (%) of Secondary schools in 1987 and the Gross enrolment ratio (%) of Tertiary schools in 1988?
Provide a short and direct response. 37.81. What is the average Gross enrolment ratio (%) in Pre-primary schools per year?
Offer a very short reply. 4.94. What is the average Gross enrolment ratio (%) in Primary schools per year?
Your answer should be compact. 100.57. What is the average Gross enrolment ratio (%) in Secondary schools per year?
Make the answer very short. 52.68. What is the average Gross enrolment ratio (%) in Tertiary schools per year?
Give a very brief answer. 16.94. In the year 1981, what is the difference between the Gross enrolment ratio (%) in Pre-primary schools and Gross enrolment ratio (%) in Primary schools?
Offer a very short reply. -92.28. In the year 1981, what is the difference between the Gross enrolment ratio (%) of Pre-primary schools and Gross enrolment ratio (%) of Secondary schools?
Keep it short and to the point. -43.86. In the year 1981, what is the difference between the Gross enrolment ratio (%) in Pre-primary schools and Gross enrolment ratio (%) in Tertiary schools?
Provide a succinct answer. -12.78. In the year 1981, what is the difference between the Gross enrolment ratio (%) in Primary schools and Gross enrolment ratio (%) in Secondary schools?
Give a very brief answer. 48.42. In the year 1981, what is the difference between the Gross enrolment ratio (%) in Primary schools and Gross enrolment ratio (%) in Tertiary schools?
Your answer should be compact. 79.5. In the year 1981, what is the difference between the Gross enrolment ratio (%) in Secondary schools and Gross enrolment ratio (%) in Tertiary schools?
Give a very brief answer. 31.09. In the year 1982, what is the difference between the Gross enrolment ratio (%) in Pre-primary schools and Gross enrolment ratio (%) in Primary schools?
Your answer should be compact. -93.32. In the year 1982, what is the difference between the Gross enrolment ratio (%) of Pre-primary schools and Gross enrolment ratio (%) of Secondary schools?
Provide a short and direct response. -44.38. In the year 1982, what is the difference between the Gross enrolment ratio (%) in Pre-primary schools and Gross enrolment ratio (%) in Tertiary schools?
Provide a short and direct response. -12.53. In the year 1982, what is the difference between the Gross enrolment ratio (%) of Primary schools and Gross enrolment ratio (%) of Secondary schools?
Provide a short and direct response. 48.94. In the year 1982, what is the difference between the Gross enrolment ratio (%) in Primary schools and Gross enrolment ratio (%) in Tertiary schools?
Ensure brevity in your answer.  80.78. In the year 1982, what is the difference between the Gross enrolment ratio (%) of Secondary schools and Gross enrolment ratio (%) of Tertiary schools?
Give a very brief answer. 31.84. In the year 1983, what is the difference between the Gross enrolment ratio (%) in Pre-primary schools and Gross enrolment ratio (%) in Primary schools?
Offer a very short reply. -93.07. In the year 1983, what is the difference between the Gross enrolment ratio (%) in Pre-primary schools and Gross enrolment ratio (%) in Secondary schools?
Ensure brevity in your answer.  -45.85. In the year 1983, what is the difference between the Gross enrolment ratio (%) of Pre-primary schools and Gross enrolment ratio (%) of Tertiary schools?
Ensure brevity in your answer.  -11.81. In the year 1983, what is the difference between the Gross enrolment ratio (%) in Primary schools and Gross enrolment ratio (%) in Secondary schools?
Your answer should be compact. 47.22. In the year 1983, what is the difference between the Gross enrolment ratio (%) in Primary schools and Gross enrolment ratio (%) in Tertiary schools?
Provide a succinct answer. 81.27. In the year 1983, what is the difference between the Gross enrolment ratio (%) in Secondary schools and Gross enrolment ratio (%) in Tertiary schools?
Offer a terse response. 34.05. In the year 1984, what is the difference between the Gross enrolment ratio (%) of Pre-primary schools and Gross enrolment ratio (%) of Primary schools?
Your response must be concise. -94.62. In the year 1984, what is the difference between the Gross enrolment ratio (%) in Pre-primary schools and Gross enrolment ratio (%) in Secondary schools?
Ensure brevity in your answer.  -48.15. In the year 1984, what is the difference between the Gross enrolment ratio (%) in Pre-primary schools and Gross enrolment ratio (%) in Tertiary schools?
Keep it short and to the point. -11.42. In the year 1984, what is the difference between the Gross enrolment ratio (%) of Primary schools and Gross enrolment ratio (%) of Secondary schools?
Your response must be concise. 46.47. In the year 1984, what is the difference between the Gross enrolment ratio (%) of Primary schools and Gross enrolment ratio (%) of Tertiary schools?
Your answer should be compact. 83.2. In the year 1984, what is the difference between the Gross enrolment ratio (%) of Secondary schools and Gross enrolment ratio (%) of Tertiary schools?
Offer a terse response. 36.73. In the year 1985, what is the difference between the Gross enrolment ratio (%) in Pre-primary schools and Gross enrolment ratio (%) in Primary schools?
Offer a very short reply. -95.67. In the year 1985, what is the difference between the Gross enrolment ratio (%) in Pre-primary schools and Gross enrolment ratio (%) in Secondary schools?
Keep it short and to the point. -49.51. In the year 1985, what is the difference between the Gross enrolment ratio (%) in Pre-primary schools and Gross enrolment ratio (%) in Tertiary schools?
Provide a succinct answer. -11.77. In the year 1985, what is the difference between the Gross enrolment ratio (%) of Primary schools and Gross enrolment ratio (%) of Secondary schools?
Keep it short and to the point. 46.16. In the year 1985, what is the difference between the Gross enrolment ratio (%) in Primary schools and Gross enrolment ratio (%) in Tertiary schools?
Provide a succinct answer. 83.9. In the year 1985, what is the difference between the Gross enrolment ratio (%) in Secondary schools and Gross enrolment ratio (%) in Tertiary schools?
Ensure brevity in your answer.  37.75. In the year 1986, what is the difference between the Gross enrolment ratio (%) in Pre-primary schools and Gross enrolment ratio (%) in Primary schools?
Your answer should be very brief. -97.48. In the year 1986, what is the difference between the Gross enrolment ratio (%) of Pre-primary schools and Gross enrolment ratio (%) of Secondary schools?
Keep it short and to the point. -50.79. In the year 1986, what is the difference between the Gross enrolment ratio (%) of Pre-primary schools and Gross enrolment ratio (%) of Tertiary schools?
Give a very brief answer. -12.03. In the year 1986, what is the difference between the Gross enrolment ratio (%) in Primary schools and Gross enrolment ratio (%) in Secondary schools?
Provide a short and direct response. 46.69. In the year 1986, what is the difference between the Gross enrolment ratio (%) of Primary schools and Gross enrolment ratio (%) of Tertiary schools?
Offer a terse response. 85.45. In the year 1986, what is the difference between the Gross enrolment ratio (%) in Secondary schools and Gross enrolment ratio (%) in Tertiary schools?
Your response must be concise. 38.76. In the year 1987, what is the difference between the Gross enrolment ratio (%) of Pre-primary schools and Gross enrolment ratio (%) of Primary schools?
Provide a succinct answer. -99.71. In the year 1987, what is the difference between the Gross enrolment ratio (%) of Pre-primary schools and Gross enrolment ratio (%) of Secondary schools?
Your answer should be very brief. -50.53. In the year 1987, what is the difference between the Gross enrolment ratio (%) of Pre-primary schools and Gross enrolment ratio (%) of Tertiary schools?
Give a very brief answer. -11.2. In the year 1987, what is the difference between the Gross enrolment ratio (%) in Primary schools and Gross enrolment ratio (%) in Secondary schools?
Ensure brevity in your answer.  49.18. In the year 1987, what is the difference between the Gross enrolment ratio (%) in Primary schools and Gross enrolment ratio (%) in Tertiary schools?
Provide a short and direct response. 88.51. In the year 1987, what is the difference between the Gross enrolment ratio (%) in Secondary schools and Gross enrolment ratio (%) in Tertiary schools?
Keep it short and to the point. 39.33. In the year 1988, what is the difference between the Gross enrolment ratio (%) of Pre-primary schools and Gross enrolment ratio (%) of Primary schools?
Give a very brief answer. -98.92. In the year 1988, what is the difference between the Gross enrolment ratio (%) of Pre-primary schools and Gross enrolment ratio (%) of Secondary schools?
Provide a short and direct response. -48.81. In the year 1988, what is the difference between the Gross enrolment ratio (%) in Pre-primary schools and Gross enrolment ratio (%) in Tertiary schools?
Your answer should be very brief. -12.47. In the year 1988, what is the difference between the Gross enrolment ratio (%) in Primary schools and Gross enrolment ratio (%) in Secondary schools?
Your answer should be very brief. 50.1. In the year 1988, what is the difference between the Gross enrolment ratio (%) of Primary schools and Gross enrolment ratio (%) of Tertiary schools?
Give a very brief answer. 86.45. In the year 1988, what is the difference between the Gross enrolment ratio (%) of Secondary schools and Gross enrolment ratio (%) of Tertiary schools?
Your response must be concise. 36.35. What is the ratio of the Gross enrolment ratio (%) in Pre-primary schools in 1981 to that in 1982?
Your answer should be very brief. 0.92. What is the ratio of the Gross enrolment ratio (%) of Primary schools in 1981 to that in 1982?
Ensure brevity in your answer.  0.99. What is the ratio of the Gross enrolment ratio (%) of Secondary schools in 1981 to that in 1982?
Give a very brief answer. 0.98. What is the ratio of the Gross enrolment ratio (%) in Pre-primary schools in 1981 to that in 1983?
Offer a terse response. 0.8. What is the ratio of the Gross enrolment ratio (%) in Primary schools in 1981 to that in 1983?
Your response must be concise. 0.98. What is the ratio of the Gross enrolment ratio (%) in Secondary schools in 1981 to that in 1983?
Ensure brevity in your answer.  0.94. What is the ratio of the Gross enrolment ratio (%) in Tertiary schools in 1981 to that in 1983?
Offer a terse response. 1.01. What is the ratio of the Gross enrolment ratio (%) of Pre-primary schools in 1981 to that in 1984?
Ensure brevity in your answer.  0.71. What is the ratio of the Gross enrolment ratio (%) in Primary schools in 1981 to that in 1984?
Make the answer very short. 0.96. What is the ratio of the Gross enrolment ratio (%) in Secondary schools in 1981 to that in 1984?
Your answer should be very brief. 0.89. What is the ratio of the Gross enrolment ratio (%) of Tertiary schools in 1981 to that in 1984?
Your response must be concise. 1. What is the ratio of the Gross enrolment ratio (%) in Pre-primary schools in 1981 to that in 1985?
Your response must be concise. 0.64. What is the ratio of the Gross enrolment ratio (%) in Primary schools in 1981 to that in 1985?
Your answer should be very brief. 0.95. What is the ratio of the Gross enrolment ratio (%) of Secondary schools in 1981 to that in 1985?
Make the answer very short. 0.86. What is the ratio of the Gross enrolment ratio (%) of Tertiary schools in 1981 to that in 1985?
Keep it short and to the point. 0.95. What is the ratio of the Gross enrolment ratio (%) in Pre-primary schools in 1981 to that in 1986?
Provide a short and direct response. 0.63. What is the ratio of the Gross enrolment ratio (%) of Primary schools in 1981 to that in 1986?
Make the answer very short. 0.93. What is the ratio of the Gross enrolment ratio (%) of Secondary schools in 1981 to that in 1986?
Your answer should be very brief. 0.84. What is the ratio of the Gross enrolment ratio (%) of Tertiary schools in 1981 to that in 1986?
Ensure brevity in your answer.  0.93. What is the ratio of the Gross enrolment ratio (%) of Pre-primary schools in 1981 to that in 1987?
Give a very brief answer. 0.57. What is the ratio of the Gross enrolment ratio (%) of Primary schools in 1981 to that in 1987?
Make the answer very short. 0.91. What is the ratio of the Gross enrolment ratio (%) of Secondary schools in 1981 to that in 1987?
Ensure brevity in your answer.  0.84. What is the ratio of the Gross enrolment ratio (%) of Tertiary schools in 1981 to that in 1987?
Provide a succinct answer. 0.94. What is the ratio of the Gross enrolment ratio (%) in Pre-primary schools in 1981 to that in 1988?
Your response must be concise. 0.55. What is the ratio of the Gross enrolment ratio (%) of Primary schools in 1981 to that in 1988?
Make the answer very short. 0.91. What is the ratio of the Gross enrolment ratio (%) of Secondary schools in 1981 to that in 1988?
Your response must be concise. 0.86. What is the ratio of the Gross enrolment ratio (%) of Tertiary schools in 1981 to that in 1988?
Ensure brevity in your answer.  0.86. What is the ratio of the Gross enrolment ratio (%) of Pre-primary schools in 1982 to that in 1983?
Your response must be concise. 0.86. What is the ratio of the Gross enrolment ratio (%) of Primary schools in 1982 to that in 1983?
Your response must be concise. 1. What is the ratio of the Gross enrolment ratio (%) of Secondary schools in 1982 to that in 1983?
Offer a terse response. 0.96. What is the ratio of the Gross enrolment ratio (%) in Tertiary schools in 1982 to that in 1983?
Your answer should be very brief. 1.01. What is the ratio of the Gross enrolment ratio (%) of Pre-primary schools in 1982 to that in 1984?
Keep it short and to the point. 0.77. What is the ratio of the Gross enrolment ratio (%) of Primary schools in 1982 to that in 1984?
Offer a very short reply. 0.98. What is the ratio of the Gross enrolment ratio (%) in Secondary schools in 1982 to that in 1984?
Give a very brief answer. 0.91. What is the ratio of the Gross enrolment ratio (%) in Tertiary schools in 1982 to that in 1984?
Your answer should be compact. 1. What is the ratio of the Gross enrolment ratio (%) in Pre-primary schools in 1982 to that in 1985?
Make the answer very short. 0.69. What is the ratio of the Gross enrolment ratio (%) in Primary schools in 1982 to that in 1985?
Give a very brief answer. 0.96. What is the ratio of the Gross enrolment ratio (%) of Secondary schools in 1982 to that in 1985?
Your answer should be very brief. 0.88. What is the ratio of the Gross enrolment ratio (%) of Tertiary schools in 1982 to that in 1985?
Give a very brief answer. 0.95. What is the ratio of the Gross enrolment ratio (%) of Pre-primary schools in 1982 to that in 1986?
Provide a short and direct response. 0.69. What is the ratio of the Gross enrolment ratio (%) of Primary schools in 1982 to that in 1986?
Offer a terse response. 0.94. What is the ratio of the Gross enrolment ratio (%) of Secondary schools in 1982 to that in 1986?
Offer a terse response. 0.86. What is the ratio of the Gross enrolment ratio (%) of Tertiary schools in 1982 to that in 1986?
Your answer should be very brief. 0.93. What is the ratio of the Gross enrolment ratio (%) of Pre-primary schools in 1982 to that in 1987?
Your answer should be compact. 0.62. What is the ratio of the Gross enrolment ratio (%) in Primary schools in 1982 to that in 1987?
Your answer should be compact. 0.92. What is the ratio of the Gross enrolment ratio (%) of Secondary schools in 1982 to that in 1987?
Provide a short and direct response. 0.85. What is the ratio of the Gross enrolment ratio (%) in Tertiary schools in 1982 to that in 1987?
Make the answer very short. 0.94. What is the ratio of the Gross enrolment ratio (%) in Pre-primary schools in 1982 to that in 1988?
Provide a succinct answer. 0.59. What is the ratio of the Gross enrolment ratio (%) in Primary schools in 1982 to that in 1988?
Give a very brief answer. 0.92. What is the ratio of the Gross enrolment ratio (%) of Secondary schools in 1982 to that in 1988?
Your answer should be compact. 0.87. What is the ratio of the Gross enrolment ratio (%) of Tertiary schools in 1982 to that in 1988?
Offer a terse response. 0.87. What is the ratio of the Gross enrolment ratio (%) of Pre-primary schools in 1983 to that in 1984?
Offer a terse response. 0.89. What is the ratio of the Gross enrolment ratio (%) in Primary schools in 1983 to that in 1984?
Your response must be concise. 0.98. What is the ratio of the Gross enrolment ratio (%) in Secondary schools in 1983 to that in 1984?
Make the answer very short. 0.95. What is the ratio of the Gross enrolment ratio (%) of Tertiary schools in 1983 to that in 1984?
Keep it short and to the point. 0.99. What is the ratio of the Gross enrolment ratio (%) of Pre-primary schools in 1983 to that in 1985?
Ensure brevity in your answer.  0.8. What is the ratio of the Gross enrolment ratio (%) in Primary schools in 1983 to that in 1985?
Offer a terse response. 0.96. What is the ratio of the Gross enrolment ratio (%) in Secondary schools in 1983 to that in 1985?
Your response must be concise. 0.91. What is the ratio of the Gross enrolment ratio (%) of Tertiary schools in 1983 to that in 1985?
Give a very brief answer. 0.94. What is the ratio of the Gross enrolment ratio (%) in Pre-primary schools in 1983 to that in 1986?
Your answer should be compact. 0.79. What is the ratio of the Gross enrolment ratio (%) of Primary schools in 1983 to that in 1986?
Ensure brevity in your answer.  0.95. What is the ratio of the Gross enrolment ratio (%) of Secondary schools in 1983 to that in 1986?
Keep it short and to the point. 0.89. What is the ratio of the Gross enrolment ratio (%) in Tertiary schools in 1983 to that in 1986?
Keep it short and to the point. 0.92. What is the ratio of the Gross enrolment ratio (%) in Pre-primary schools in 1983 to that in 1987?
Keep it short and to the point. 0.71. What is the ratio of the Gross enrolment ratio (%) of Primary schools in 1983 to that in 1987?
Ensure brevity in your answer.  0.92. What is the ratio of the Gross enrolment ratio (%) of Secondary schools in 1983 to that in 1987?
Ensure brevity in your answer.  0.89. What is the ratio of the Gross enrolment ratio (%) of Tertiary schools in 1983 to that in 1987?
Give a very brief answer. 0.93. What is the ratio of the Gross enrolment ratio (%) of Pre-primary schools in 1983 to that in 1988?
Offer a terse response. 0.69. What is the ratio of the Gross enrolment ratio (%) of Primary schools in 1983 to that in 1988?
Make the answer very short. 0.93. What is the ratio of the Gross enrolment ratio (%) of Secondary schools in 1983 to that in 1988?
Make the answer very short. 0.91. What is the ratio of the Gross enrolment ratio (%) of Tertiary schools in 1983 to that in 1988?
Provide a short and direct response. 0.86. What is the ratio of the Gross enrolment ratio (%) in Pre-primary schools in 1984 to that in 1985?
Your answer should be very brief. 0.9. What is the ratio of the Gross enrolment ratio (%) of Primary schools in 1984 to that in 1985?
Offer a very short reply. 0.98. What is the ratio of the Gross enrolment ratio (%) of Secondary schools in 1984 to that in 1985?
Offer a terse response. 0.97. What is the ratio of the Gross enrolment ratio (%) of Tertiary schools in 1984 to that in 1985?
Offer a very short reply. 0.95. What is the ratio of the Gross enrolment ratio (%) of Pre-primary schools in 1984 to that in 1986?
Make the answer very short. 0.89. What is the ratio of the Gross enrolment ratio (%) of Primary schools in 1984 to that in 1986?
Provide a succinct answer. 0.97. What is the ratio of the Gross enrolment ratio (%) of Secondary schools in 1984 to that in 1986?
Offer a very short reply. 0.94. What is the ratio of the Gross enrolment ratio (%) of Tertiary schools in 1984 to that in 1986?
Offer a very short reply. 0.93. What is the ratio of the Gross enrolment ratio (%) of Pre-primary schools in 1984 to that in 1987?
Offer a very short reply. 0.8. What is the ratio of the Gross enrolment ratio (%) in Primary schools in 1984 to that in 1987?
Keep it short and to the point. 0.94. What is the ratio of the Gross enrolment ratio (%) of Secondary schools in 1984 to that in 1987?
Keep it short and to the point. 0.94. What is the ratio of the Gross enrolment ratio (%) of Tertiary schools in 1984 to that in 1987?
Your response must be concise. 0.94. What is the ratio of the Gross enrolment ratio (%) in Pre-primary schools in 1984 to that in 1988?
Your answer should be compact. 0.77. What is the ratio of the Gross enrolment ratio (%) of Primary schools in 1984 to that in 1988?
Offer a very short reply. 0.95. What is the ratio of the Gross enrolment ratio (%) of Secondary schools in 1984 to that in 1988?
Offer a very short reply. 0.96. What is the ratio of the Gross enrolment ratio (%) in Tertiary schools in 1984 to that in 1988?
Ensure brevity in your answer.  0.87. What is the ratio of the Gross enrolment ratio (%) of Pre-primary schools in 1985 to that in 1986?
Offer a very short reply. 0.99. What is the ratio of the Gross enrolment ratio (%) of Secondary schools in 1985 to that in 1986?
Make the answer very short. 0.98. What is the ratio of the Gross enrolment ratio (%) of Tertiary schools in 1985 to that in 1986?
Offer a terse response. 0.98. What is the ratio of the Gross enrolment ratio (%) in Pre-primary schools in 1985 to that in 1987?
Keep it short and to the point. 0.89. What is the ratio of the Gross enrolment ratio (%) in Primary schools in 1985 to that in 1987?
Offer a very short reply. 0.96. What is the ratio of the Gross enrolment ratio (%) of Secondary schools in 1985 to that in 1987?
Your answer should be compact. 0.97. What is the ratio of the Gross enrolment ratio (%) of Tertiary schools in 1985 to that in 1987?
Make the answer very short. 0.99. What is the ratio of the Gross enrolment ratio (%) in Pre-primary schools in 1985 to that in 1988?
Provide a short and direct response. 0.86. What is the ratio of the Gross enrolment ratio (%) in Primary schools in 1985 to that in 1988?
Offer a very short reply. 0.96. What is the ratio of the Gross enrolment ratio (%) of Secondary schools in 1985 to that in 1988?
Keep it short and to the point. 1. What is the ratio of the Gross enrolment ratio (%) in Tertiary schools in 1985 to that in 1988?
Your answer should be very brief. 0.91. What is the ratio of the Gross enrolment ratio (%) in Pre-primary schools in 1986 to that in 1987?
Ensure brevity in your answer.  0.9. What is the ratio of the Gross enrolment ratio (%) of Primary schools in 1986 to that in 1987?
Your answer should be compact. 0.97. What is the ratio of the Gross enrolment ratio (%) of Secondary schools in 1986 to that in 1987?
Your answer should be compact. 0.99. What is the ratio of the Gross enrolment ratio (%) in Tertiary schools in 1986 to that in 1987?
Offer a terse response. 1.01. What is the ratio of the Gross enrolment ratio (%) in Pre-primary schools in 1986 to that in 1988?
Give a very brief answer. 0.86. What is the ratio of the Gross enrolment ratio (%) in Primary schools in 1986 to that in 1988?
Your response must be concise. 0.98. What is the ratio of the Gross enrolment ratio (%) in Secondary schools in 1986 to that in 1988?
Offer a very short reply. 1.02. What is the ratio of the Gross enrolment ratio (%) of Tertiary schools in 1986 to that in 1988?
Make the answer very short. 0.93. What is the ratio of the Gross enrolment ratio (%) in Pre-primary schools in 1987 to that in 1988?
Keep it short and to the point. 0.96. What is the ratio of the Gross enrolment ratio (%) in Primary schools in 1987 to that in 1988?
Make the answer very short. 1.01. What is the ratio of the Gross enrolment ratio (%) in Secondary schools in 1987 to that in 1988?
Offer a terse response. 1.03. What is the ratio of the Gross enrolment ratio (%) of Tertiary schools in 1987 to that in 1988?
Keep it short and to the point. 0.92. What is the difference between the highest and the second highest Gross enrolment ratio (%) in Pre-primary schools?
Make the answer very short. 0.25. What is the difference between the highest and the second highest Gross enrolment ratio (%) in Primary schools?
Offer a terse response. 0.54. What is the difference between the highest and the second highest Gross enrolment ratio (%) in Secondary schools?
Keep it short and to the point. 0.35. What is the difference between the highest and the second highest Gross enrolment ratio (%) of Tertiary schools?
Keep it short and to the point. 1.31. What is the difference between the highest and the lowest Gross enrolment ratio (%) of Pre-primary schools?
Give a very brief answer. 2.86. What is the difference between the highest and the lowest Gross enrolment ratio (%) in Primary schools?
Your answer should be very brief. 10.04. What is the difference between the highest and the lowest Gross enrolment ratio (%) in Secondary schools?
Provide a short and direct response. 9.27. What is the difference between the highest and the lowest Gross enrolment ratio (%) of Tertiary schools?
Offer a terse response. 2.64. 